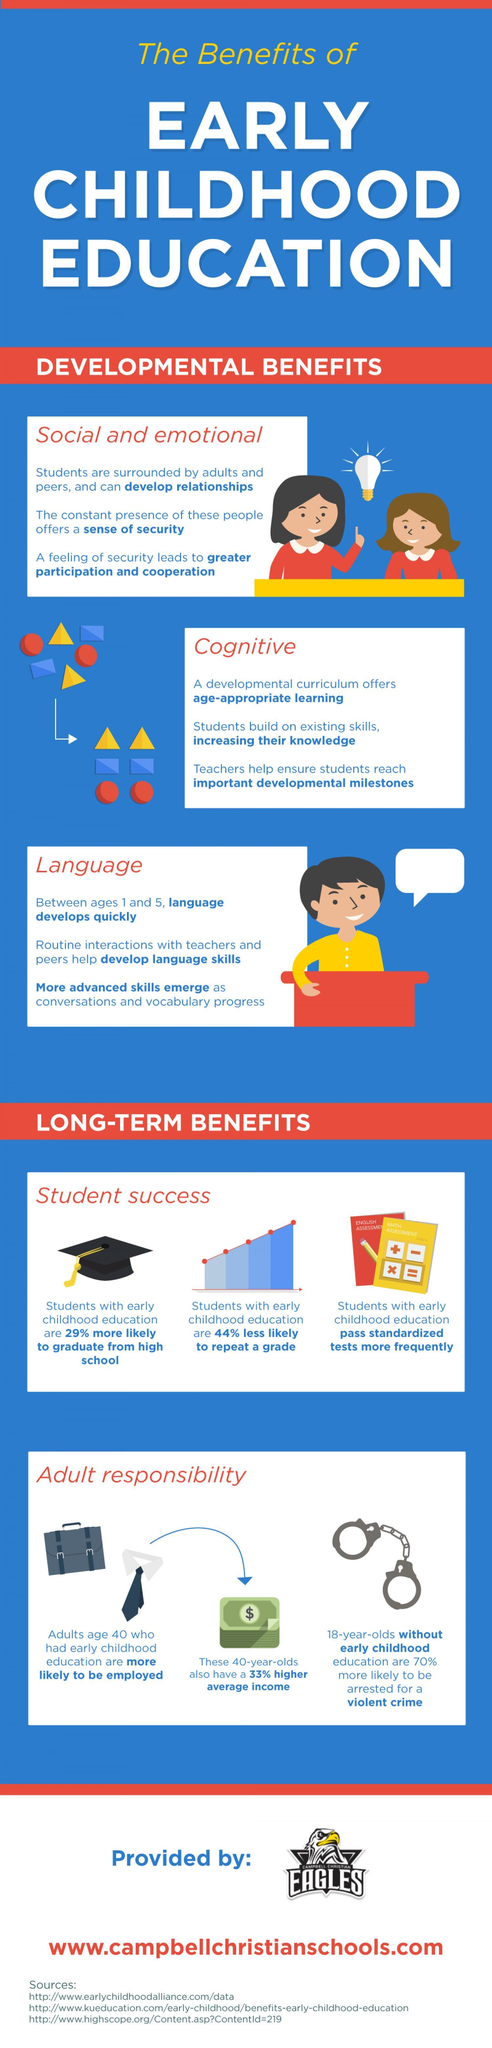What is the long term benefit of early childhood education?
Answer the question with a short phrase. Student success, Adult responsibility How many developmental benefits for early childhood education? 3 What are the developmental benefits of early childhood education? Social and emotional, Cognitive, Language 